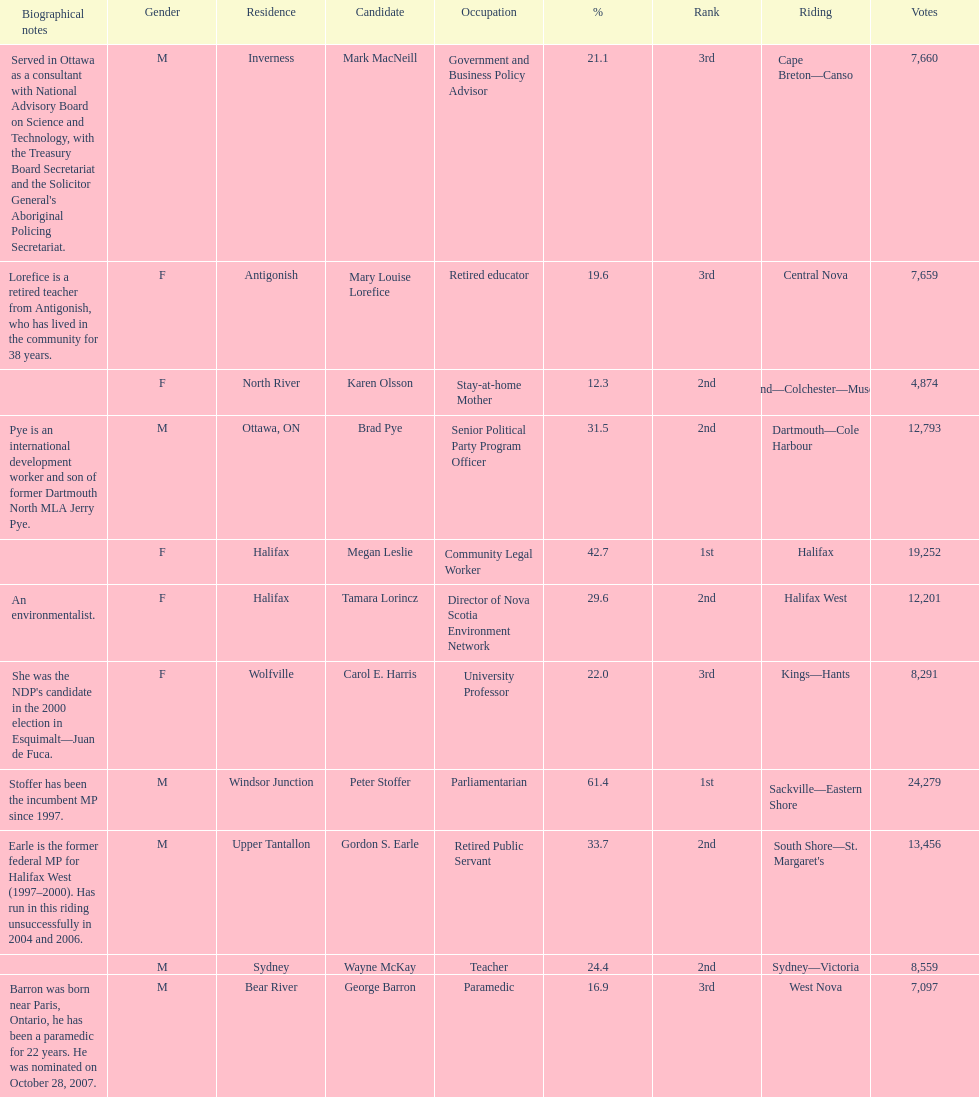Who are all the candidates? Mark MacNeill, Mary Louise Lorefice, Karen Olsson, Brad Pye, Megan Leslie, Tamara Lorincz, Carol E. Harris, Peter Stoffer, Gordon S. Earle, Wayne McKay, George Barron. How many votes did they receive? 7,660, 7,659, 4,874, 12,793, 19,252, 12,201, 8,291, 24,279, 13,456, 8,559, 7,097. And of those, how many were for megan leslie? 19,252. 